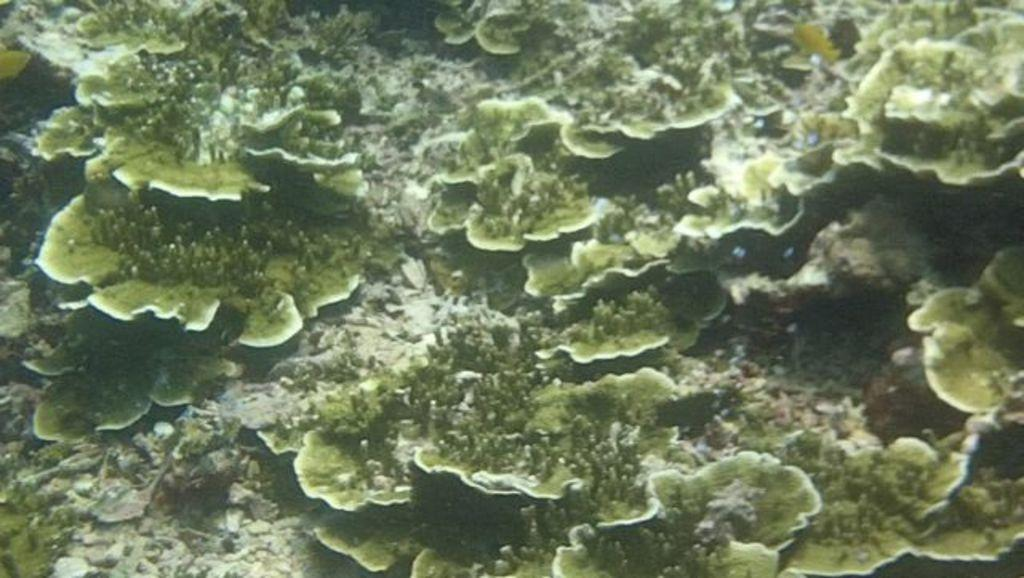What type of environment is shown in the image? The image depicts an underwater environment. Can you describe any specific features of the underwater environment? Unfortunately, the provided facts do not give any specific details about the underwater environment. Are there any living organisms visible in the image? The provided facts do not mention any living organisms in the image. How much butter is present in the image? There is no butter present in the image, as it depicts an underwater environment. 